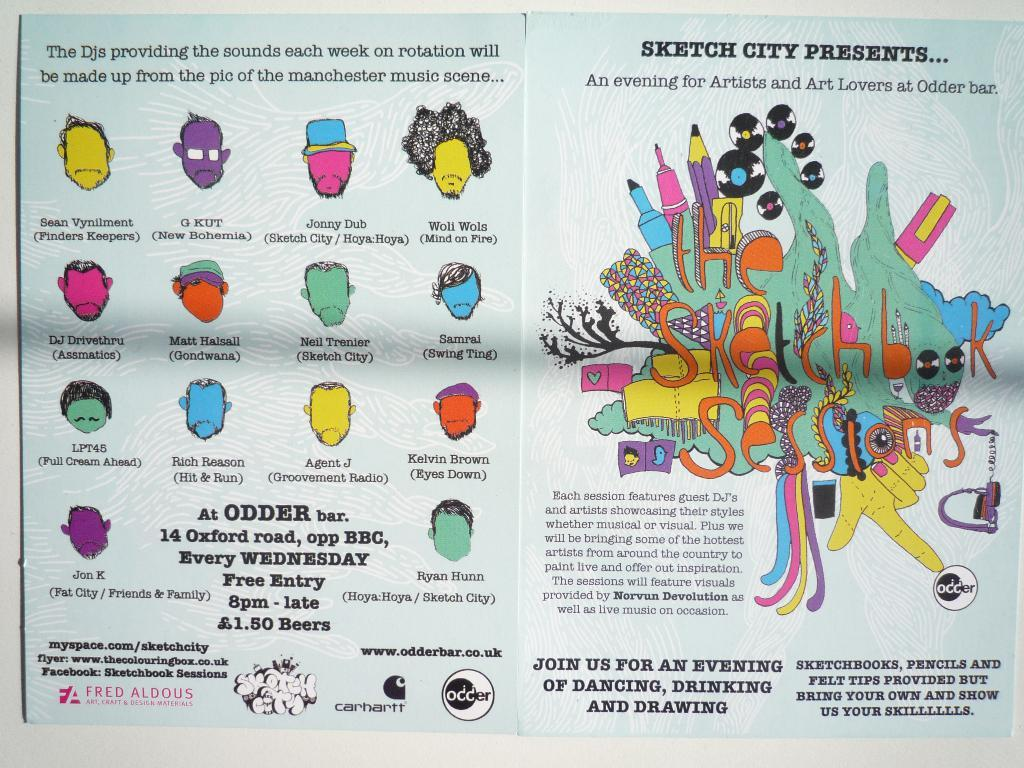<image>
Render a clear and concise summary of the photo. Odder Bar hosts a free art night every Wednesday. 